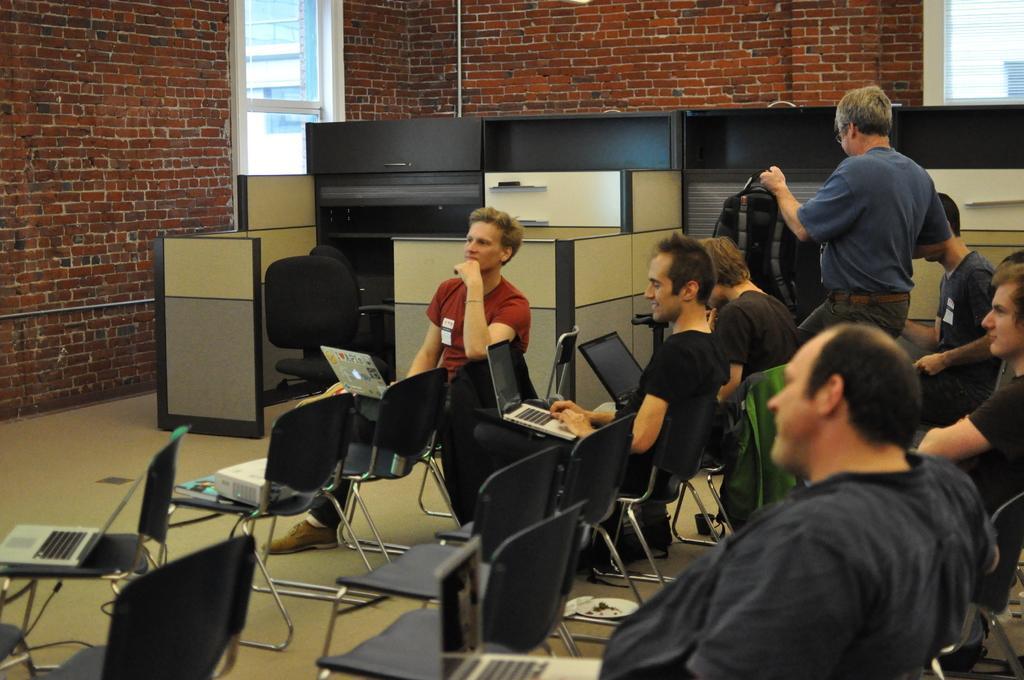Can you describe this image briefly? In the picture there are few people sitting on chairs. They all are holding laptops in the hand. There is a man standing and holding a backpack in his hand. Behind them there are cabins and racks. On one of the chair there is a projector. In the background there is wall of red bricks and glass windows. 